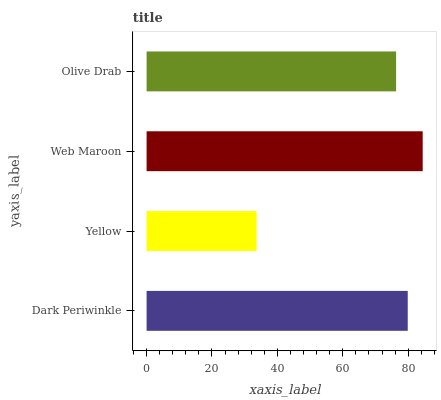Is Yellow the minimum?
Answer yes or no. Yes. Is Web Maroon the maximum?
Answer yes or no. Yes. Is Web Maroon the minimum?
Answer yes or no. No. Is Yellow the maximum?
Answer yes or no. No. Is Web Maroon greater than Yellow?
Answer yes or no. Yes. Is Yellow less than Web Maroon?
Answer yes or no. Yes. Is Yellow greater than Web Maroon?
Answer yes or no. No. Is Web Maroon less than Yellow?
Answer yes or no. No. Is Dark Periwinkle the high median?
Answer yes or no. Yes. Is Olive Drab the low median?
Answer yes or no. Yes. Is Web Maroon the high median?
Answer yes or no. No. Is Dark Periwinkle the low median?
Answer yes or no. No. 